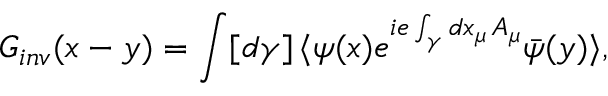<formula> <loc_0><loc_0><loc_500><loc_500>G _ { i n v } ( x - y ) = \int [ d \gamma ] \, \langle \psi ( x ) e ^ { i e \int _ { \gamma } d x _ { \mu } \, A _ { \mu } } \bar { \psi } ( y ) \rangle ,</formula> 